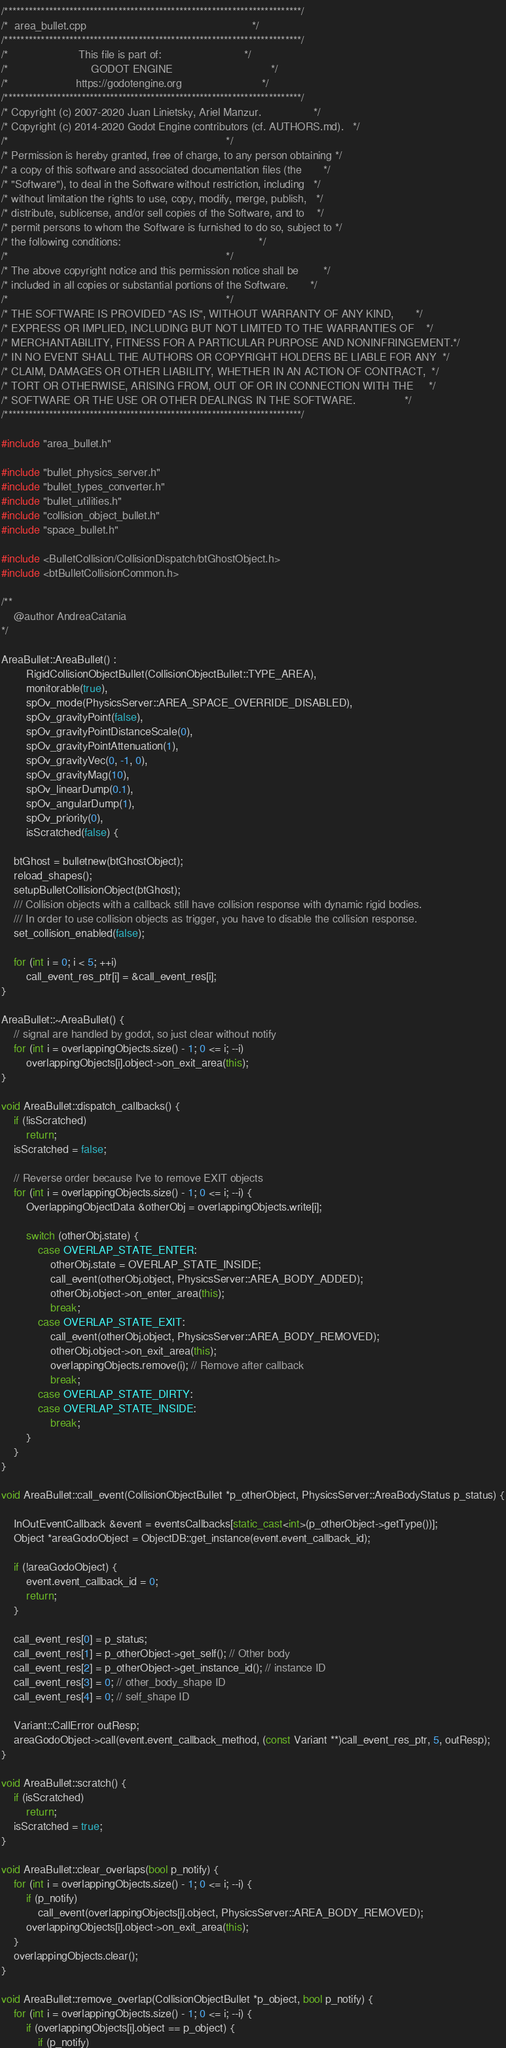Convert code to text. <code><loc_0><loc_0><loc_500><loc_500><_C++_>/*************************************************************************/
/*  area_bullet.cpp                                                      */
/*************************************************************************/
/*                       This file is part of:                           */
/*                           GODOT ENGINE                                */
/*                      https://godotengine.org                          */
/*************************************************************************/
/* Copyright (c) 2007-2020 Juan Linietsky, Ariel Manzur.                 */
/* Copyright (c) 2014-2020 Godot Engine contributors (cf. AUTHORS.md).   */
/*                                                                       */
/* Permission is hereby granted, free of charge, to any person obtaining */
/* a copy of this software and associated documentation files (the       */
/* "Software"), to deal in the Software without restriction, including   */
/* without limitation the rights to use, copy, modify, merge, publish,   */
/* distribute, sublicense, and/or sell copies of the Software, and to    */
/* permit persons to whom the Software is furnished to do so, subject to */
/* the following conditions:                                             */
/*                                                                       */
/* The above copyright notice and this permission notice shall be        */
/* included in all copies or substantial portions of the Software.       */
/*                                                                       */
/* THE SOFTWARE IS PROVIDED "AS IS", WITHOUT WARRANTY OF ANY KIND,       */
/* EXPRESS OR IMPLIED, INCLUDING BUT NOT LIMITED TO THE WARRANTIES OF    */
/* MERCHANTABILITY, FITNESS FOR A PARTICULAR PURPOSE AND NONINFRINGEMENT.*/
/* IN NO EVENT SHALL THE AUTHORS OR COPYRIGHT HOLDERS BE LIABLE FOR ANY  */
/* CLAIM, DAMAGES OR OTHER LIABILITY, WHETHER IN AN ACTION OF CONTRACT,  */
/* TORT OR OTHERWISE, ARISING FROM, OUT OF OR IN CONNECTION WITH THE     */
/* SOFTWARE OR THE USE OR OTHER DEALINGS IN THE SOFTWARE.                */
/*************************************************************************/

#include "area_bullet.h"

#include "bullet_physics_server.h"
#include "bullet_types_converter.h"
#include "bullet_utilities.h"
#include "collision_object_bullet.h"
#include "space_bullet.h"

#include <BulletCollision/CollisionDispatch/btGhostObject.h>
#include <btBulletCollisionCommon.h>

/**
	@author AndreaCatania
*/

AreaBullet::AreaBullet() :
		RigidCollisionObjectBullet(CollisionObjectBullet::TYPE_AREA),
		monitorable(true),
		spOv_mode(PhysicsServer::AREA_SPACE_OVERRIDE_DISABLED),
		spOv_gravityPoint(false),
		spOv_gravityPointDistanceScale(0),
		spOv_gravityPointAttenuation(1),
		spOv_gravityVec(0, -1, 0),
		spOv_gravityMag(10),
		spOv_linearDump(0.1),
		spOv_angularDump(1),
		spOv_priority(0),
		isScratched(false) {

	btGhost = bulletnew(btGhostObject);
	reload_shapes();
	setupBulletCollisionObject(btGhost);
	/// Collision objects with a callback still have collision response with dynamic rigid bodies.
	/// In order to use collision objects as trigger, you have to disable the collision response.
	set_collision_enabled(false);

	for (int i = 0; i < 5; ++i)
		call_event_res_ptr[i] = &call_event_res[i];
}

AreaBullet::~AreaBullet() {
	// signal are handled by godot, so just clear without notify
	for (int i = overlappingObjects.size() - 1; 0 <= i; --i)
		overlappingObjects[i].object->on_exit_area(this);
}

void AreaBullet::dispatch_callbacks() {
	if (!isScratched)
		return;
	isScratched = false;

	// Reverse order because I've to remove EXIT objects
	for (int i = overlappingObjects.size() - 1; 0 <= i; --i) {
		OverlappingObjectData &otherObj = overlappingObjects.write[i];

		switch (otherObj.state) {
			case OVERLAP_STATE_ENTER:
				otherObj.state = OVERLAP_STATE_INSIDE;
				call_event(otherObj.object, PhysicsServer::AREA_BODY_ADDED);
				otherObj.object->on_enter_area(this);
				break;
			case OVERLAP_STATE_EXIT:
				call_event(otherObj.object, PhysicsServer::AREA_BODY_REMOVED);
				otherObj.object->on_exit_area(this);
				overlappingObjects.remove(i); // Remove after callback
				break;
			case OVERLAP_STATE_DIRTY:
			case OVERLAP_STATE_INSIDE:
				break;
		}
	}
}

void AreaBullet::call_event(CollisionObjectBullet *p_otherObject, PhysicsServer::AreaBodyStatus p_status) {

	InOutEventCallback &event = eventsCallbacks[static_cast<int>(p_otherObject->getType())];
	Object *areaGodoObject = ObjectDB::get_instance(event.event_callback_id);

	if (!areaGodoObject) {
		event.event_callback_id = 0;
		return;
	}

	call_event_res[0] = p_status;
	call_event_res[1] = p_otherObject->get_self(); // Other body
	call_event_res[2] = p_otherObject->get_instance_id(); // instance ID
	call_event_res[3] = 0; // other_body_shape ID
	call_event_res[4] = 0; // self_shape ID

	Variant::CallError outResp;
	areaGodoObject->call(event.event_callback_method, (const Variant **)call_event_res_ptr, 5, outResp);
}

void AreaBullet::scratch() {
	if (isScratched)
		return;
	isScratched = true;
}

void AreaBullet::clear_overlaps(bool p_notify) {
	for (int i = overlappingObjects.size() - 1; 0 <= i; --i) {
		if (p_notify)
			call_event(overlappingObjects[i].object, PhysicsServer::AREA_BODY_REMOVED);
		overlappingObjects[i].object->on_exit_area(this);
	}
	overlappingObjects.clear();
}

void AreaBullet::remove_overlap(CollisionObjectBullet *p_object, bool p_notify) {
	for (int i = overlappingObjects.size() - 1; 0 <= i; --i) {
		if (overlappingObjects[i].object == p_object) {
			if (p_notify)</code> 